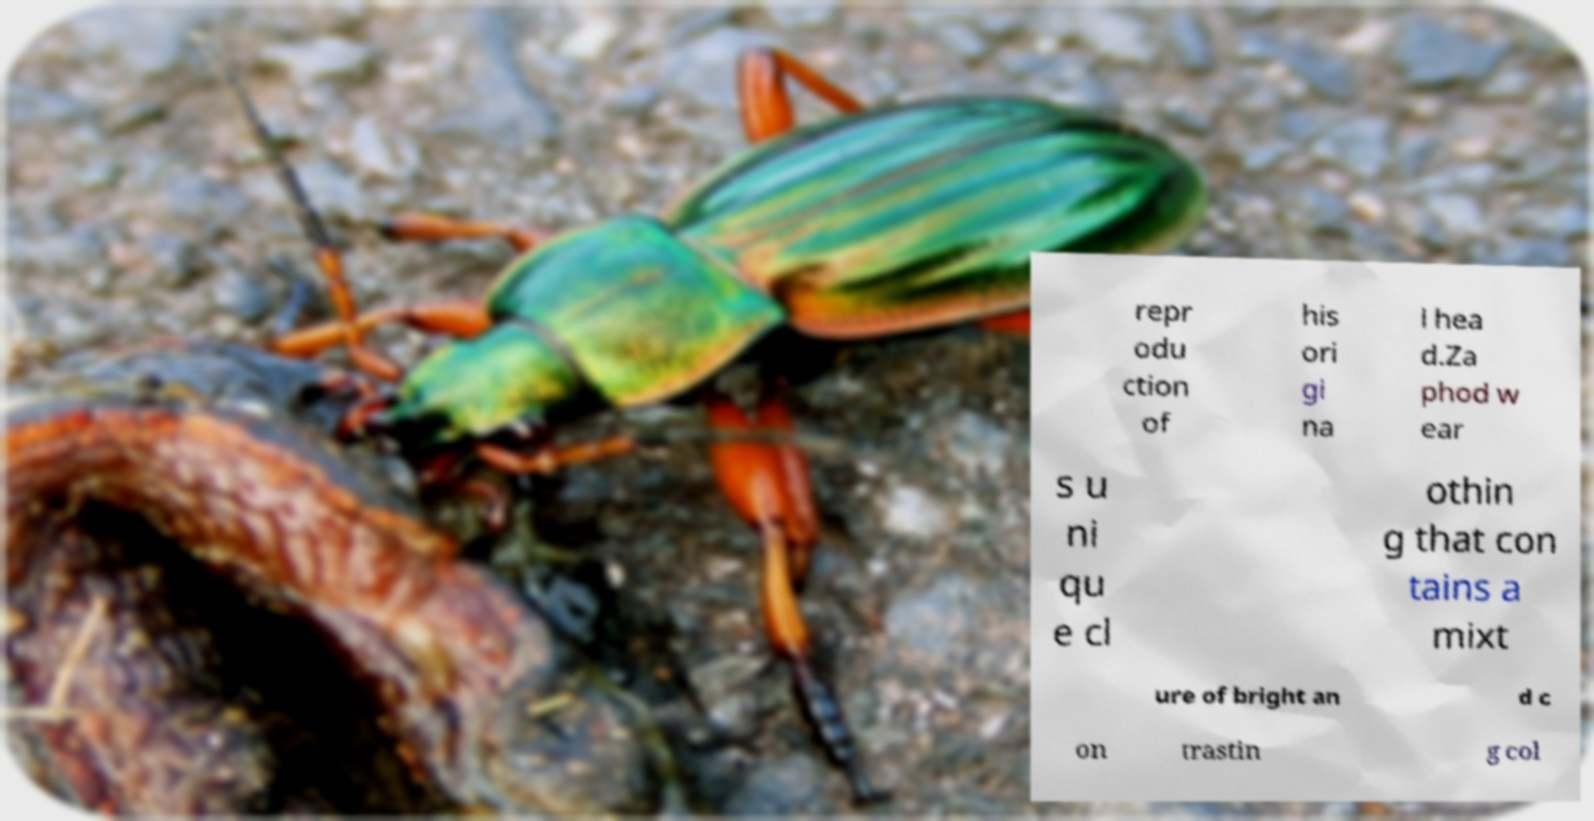Please read and relay the text visible in this image. What does it say? repr odu ction of his ori gi na l hea d.Za phod w ear s u ni qu e cl othin g that con tains a mixt ure of bright an d c on trastin g col 